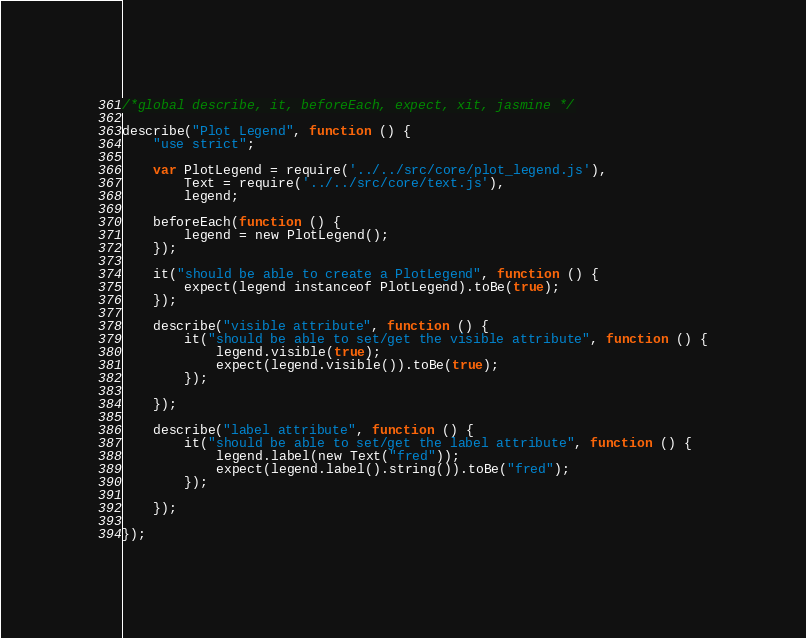<code> <loc_0><loc_0><loc_500><loc_500><_JavaScript_>/*global describe, it, beforeEach, expect, xit, jasmine */

describe("Plot Legend", function () {
    "use strict";

    var PlotLegend = require('../../src/core/plot_legend.js'),
        Text = require('../../src/core/text.js'),
        legend;

    beforeEach(function () {
        legend = new PlotLegend();
    });

    it("should be able to create a PlotLegend", function () {
        expect(legend instanceof PlotLegend).toBe(true);
    });

    describe("visible attribute", function () {
        it("should be able to set/get the visible attribute", function () {
            legend.visible(true);
            expect(legend.visible()).toBe(true);
        });

    });

    describe("label attribute", function () {
        it("should be able to set/get the label attribute", function () {
            legend.label(new Text("fred"));
            expect(legend.label().string()).toBe("fred");
        });

    });

});
</code> 